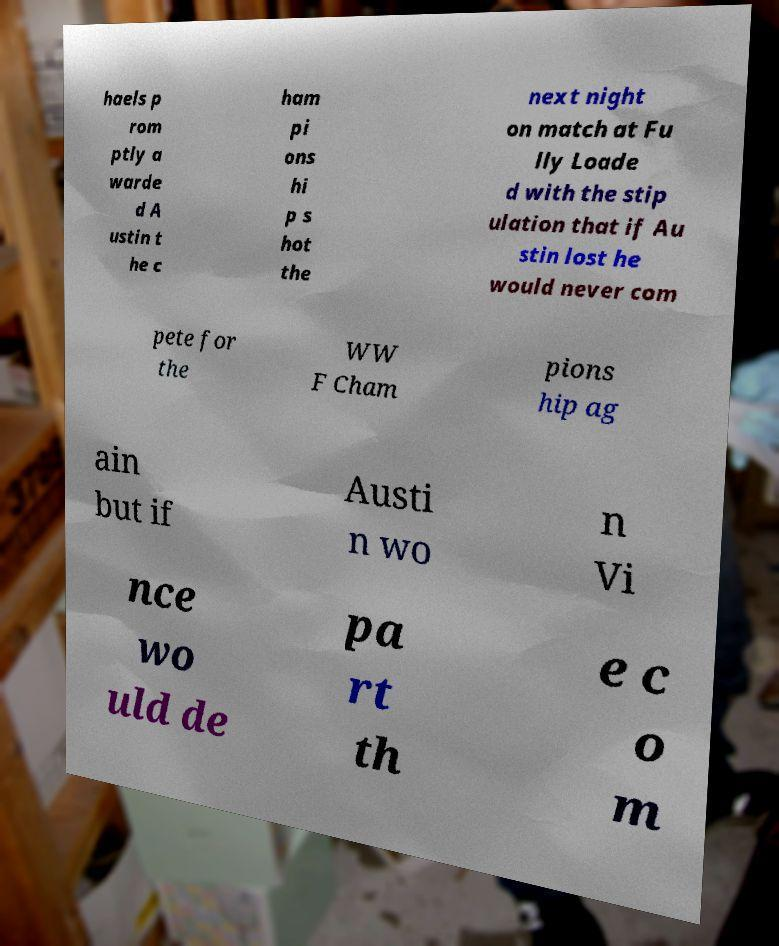Could you extract and type out the text from this image? haels p rom ptly a warde d A ustin t he c ham pi ons hi p s hot the next night on match at Fu lly Loade d with the stip ulation that if Au stin lost he would never com pete for the WW F Cham pions hip ag ain but if Austi n wo n Vi nce wo uld de pa rt th e c o m 